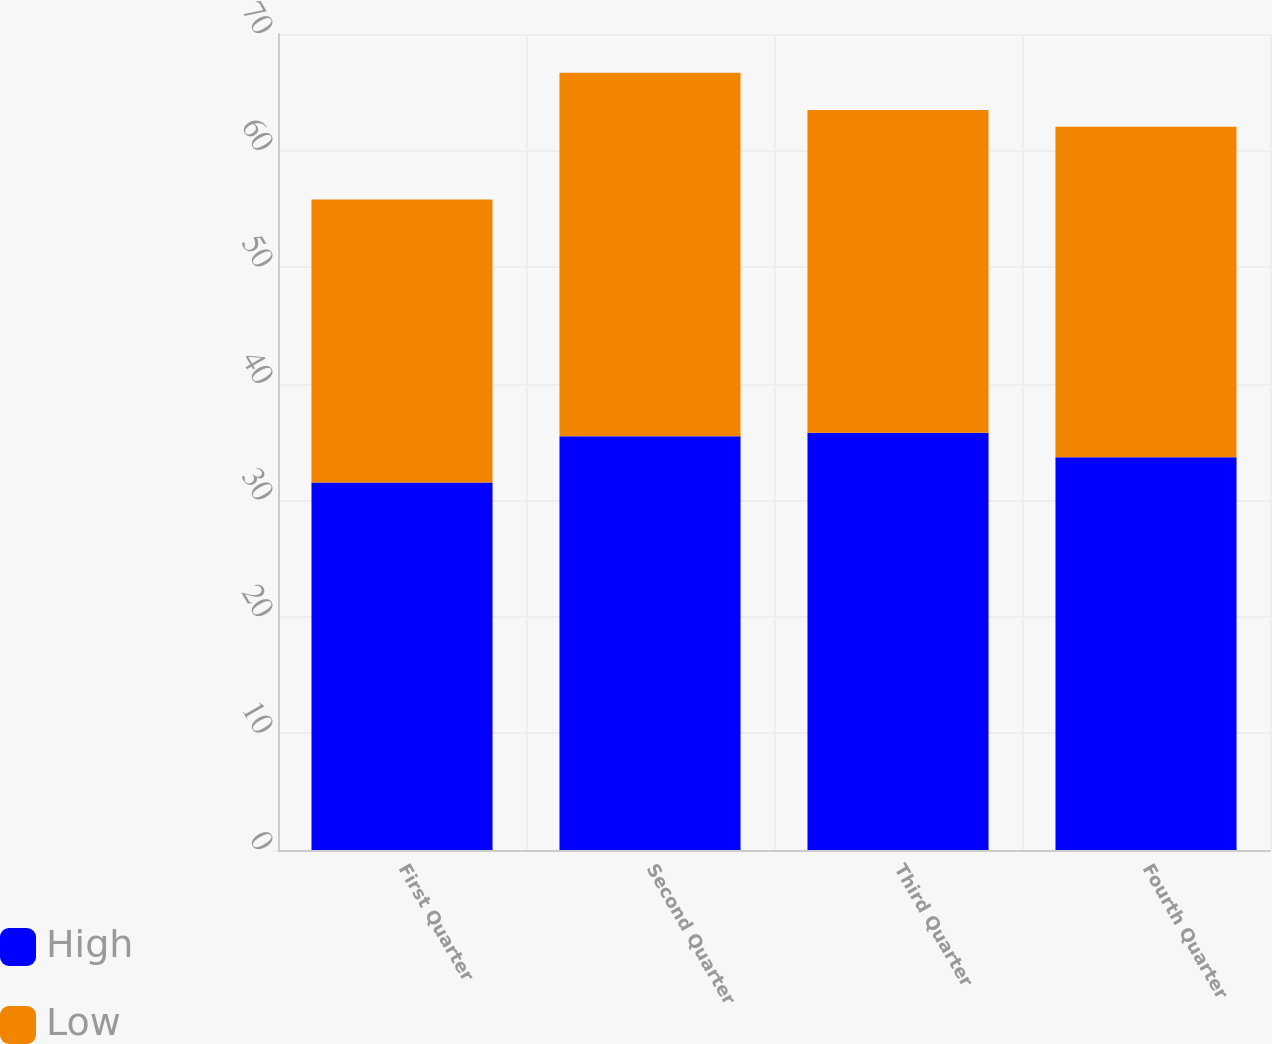Convert chart. <chart><loc_0><loc_0><loc_500><loc_500><stacked_bar_chart><ecel><fcel>First Quarter<fcel>Second Quarter<fcel>Third Quarter<fcel>Fourth Quarter<nl><fcel>High<fcel>31.53<fcel>35.5<fcel>35.79<fcel>33.7<nl><fcel>Low<fcel>24.28<fcel>31.18<fcel>27.68<fcel>28.34<nl></chart> 